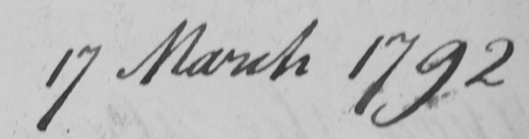Transcribe the text shown in this historical manuscript line. 17 March 1792 